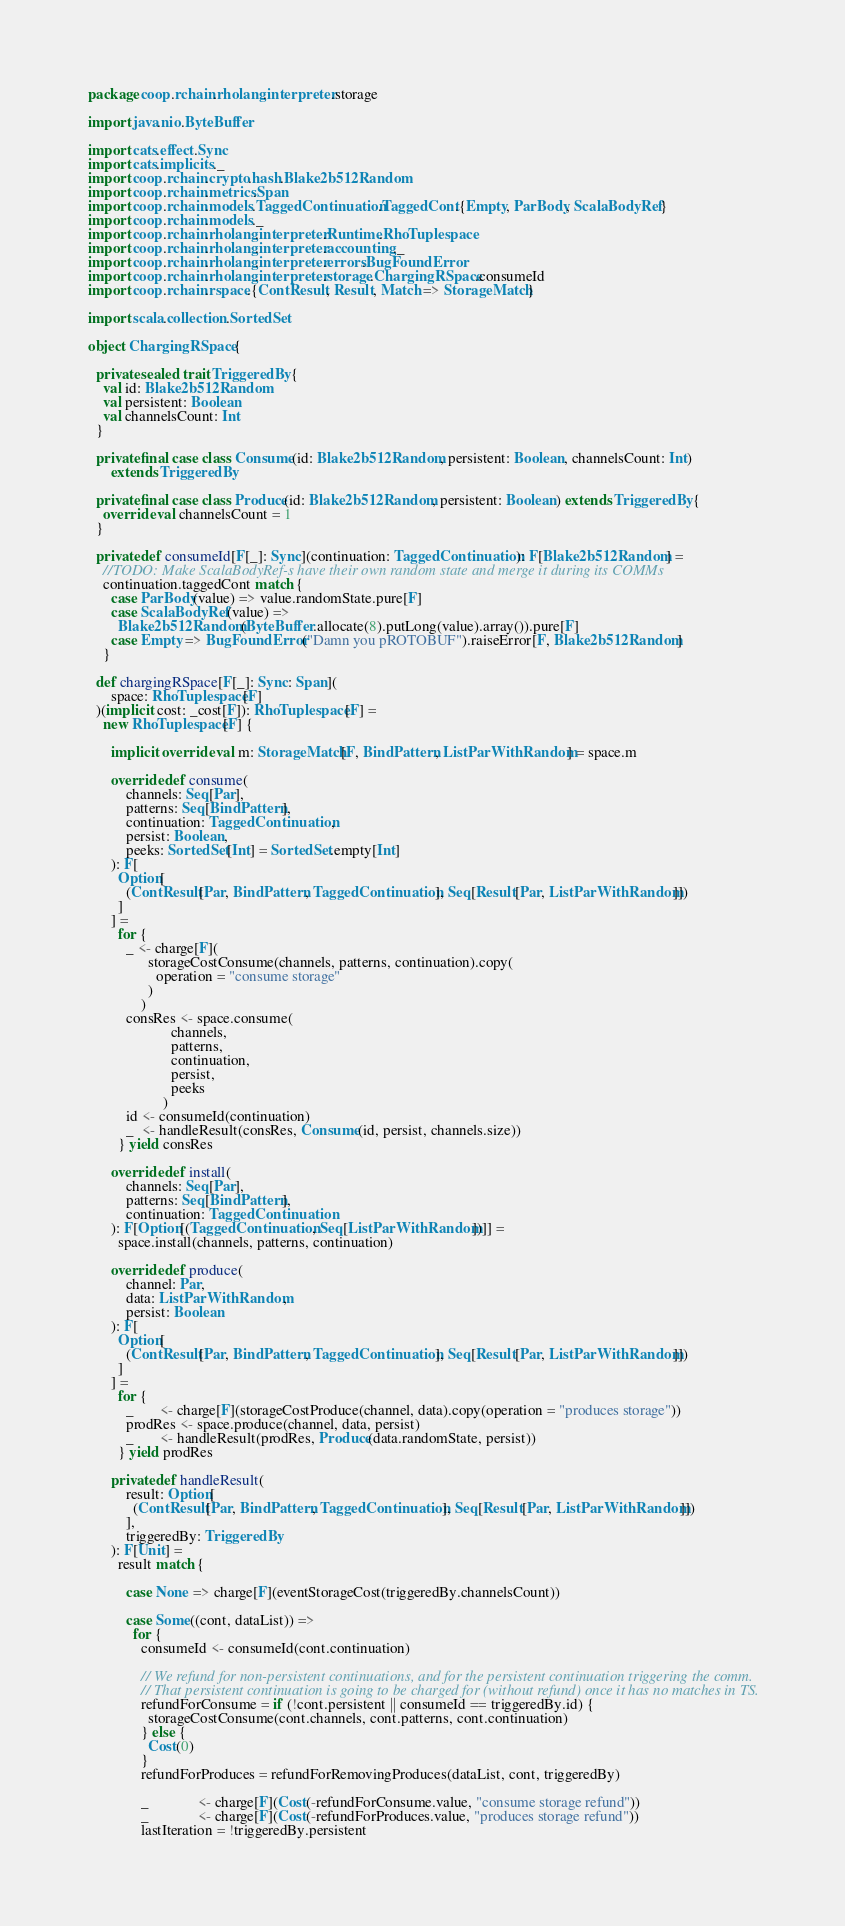<code> <loc_0><loc_0><loc_500><loc_500><_Scala_>package coop.rchain.rholang.interpreter.storage

import java.nio.ByteBuffer

import cats.effect.Sync
import cats.implicits._
import coop.rchain.crypto.hash.Blake2b512Random
import coop.rchain.metrics.Span
import coop.rchain.models.TaggedContinuation.TaggedCont.{Empty, ParBody, ScalaBodyRef}
import coop.rchain.models._
import coop.rchain.rholang.interpreter.Runtime.RhoTuplespace
import coop.rchain.rholang.interpreter.accounting._
import coop.rchain.rholang.interpreter.errors.BugFoundError
import coop.rchain.rholang.interpreter.storage.ChargingRSpace.consumeId
import coop.rchain.rspace.{ContResult, Result, Match => StorageMatch}

import scala.collection.SortedSet

object ChargingRSpace {

  private sealed trait TriggeredBy {
    val id: Blake2b512Random
    val persistent: Boolean
    val channelsCount: Int
  }

  private final case class Consume(id: Blake2b512Random, persistent: Boolean, channelsCount: Int)
      extends TriggeredBy

  private final case class Produce(id: Blake2b512Random, persistent: Boolean) extends TriggeredBy {
    override val channelsCount = 1
  }

  private def consumeId[F[_]: Sync](continuation: TaggedContinuation): F[Blake2b512Random] =
    //TODO: Make ScalaBodyRef-s have their own random state and merge it during its COMMs
    continuation.taggedCont match {
      case ParBody(value) => value.randomState.pure[F]
      case ScalaBodyRef(value) =>
        Blake2b512Random(ByteBuffer.allocate(8).putLong(value).array()).pure[F]
      case Empty => BugFoundError("Damn you pROTOBUF").raiseError[F, Blake2b512Random]
    }

  def chargingRSpace[F[_]: Sync: Span](
      space: RhoTuplespace[F]
  )(implicit cost: _cost[F]): RhoTuplespace[F] =
    new RhoTuplespace[F] {

      implicit override val m: StorageMatch[F, BindPattern, ListParWithRandom] = space.m

      override def consume(
          channels: Seq[Par],
          patterns: Seq[BindPattern],
          continuation: TaggedContinuation,
          persist: Boolean,
          peeks: SortedSet[Int] = SortedSet.empty[Int]
      ): F[
        Option[
          (ContResult[Par, BindPattern, TaggedContinuation], Seq[Result[Par, ListParWithRandom]])
        ]
      ] =
        for {
          _ <- charge[F](
                storageCostConsume(channels, patterns, continuation).copy(
                  operation = "consume storage"
                )
              )
          consRes <- space.consume(
                      channels,
                      patterns,
                      continuation,
                      persist,
                      peeks
                    )
          id <- consumeId(continuation)
          _  <- handleResult(consRes, Consume(id, persist, channels.size))
        } yield consRes

      override def install(
          channels: Seq[Par],
          patterns: Seq[BindPattern],
          continuation: TaggedContinuation
      ): F[Option[(TaggedContinuation, Seq[ListParWithRandom])]] =
        space.install(channels, patterns, continuation)

      override def produce(
          channel: Par,
          data: ListParWithRandom,
          persist: Boolean
      ): F[
        Option[
          (ContResult[Par, BindPattern, TaggedContinuation], Seq[Result[Par, ListParWithRandom]])
        ]
      ] =
        for {
          _       <- charge[F](storageCostProduce(channel, data).copy(operation = "produces storage"))
          prodRes <- space.produce(channel, data, persist)
          _       <- handleResult(prodRes, Produce(data.randomState, persist))
        } yield prodRes

      private def handleResult(
          result: Option[
            (ContResult[Par, BindPattern, TaggedContinuation], Seq[Result[Par, ListParWithRandom]])
          ],
          triggeredBy: TriggeredBy
      ): F[Unit] =
        result match {

          case None => charge[F](eventStorageCost(triggeredBy.channelsCount))

          case Some((cont, dataList)) =>
            for {
              consumeId <- consumeId(cont.continuation)

              // We refund for non-persistent continuations, and for the persistent continuation triggering the comm.
              // That persistent continuation is going to be charged for (without refund) once it has no matches in TS.
              refundForConsume = if (!cont.persistent || consumeId == triggeredBy.id) {
                storageCostConsume(cont.channels, cont.patterns, cont.continuation)
              } else {
                Cost(0)
              }
              refundForProduces = refundForRemovingProduces(dataList, cont, triggeredBy)

              _             <- charge[F](Cost(-refundForConsume.value, "consume storage refund"))
              _             <- charge[F](Cost(-refundForProduces.value, "produces storage refund"))
              lastIteration = !triggeredBy.persistent</code> 